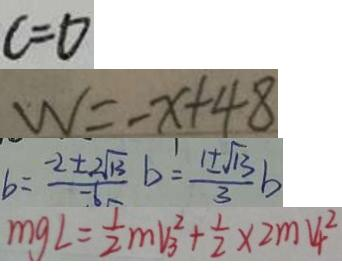<formula> <loc_0><loc_0><loc_500><loc_500>c = 0 
 W = - x + 4 8 
 b = \frac { - 2 \pm 2 \sqrt { 1 3 } } { - 6 } b = \frac { 1 \pm \sqrt { 1 3 } } { 3 } b 
 m g L = \frac { 1 } { 2 } m V _ { 3 } ^ { 2 } + \frac { 1 } { 2 } \times 2 m V ^ { 2 } _ { 4 }</formula> 